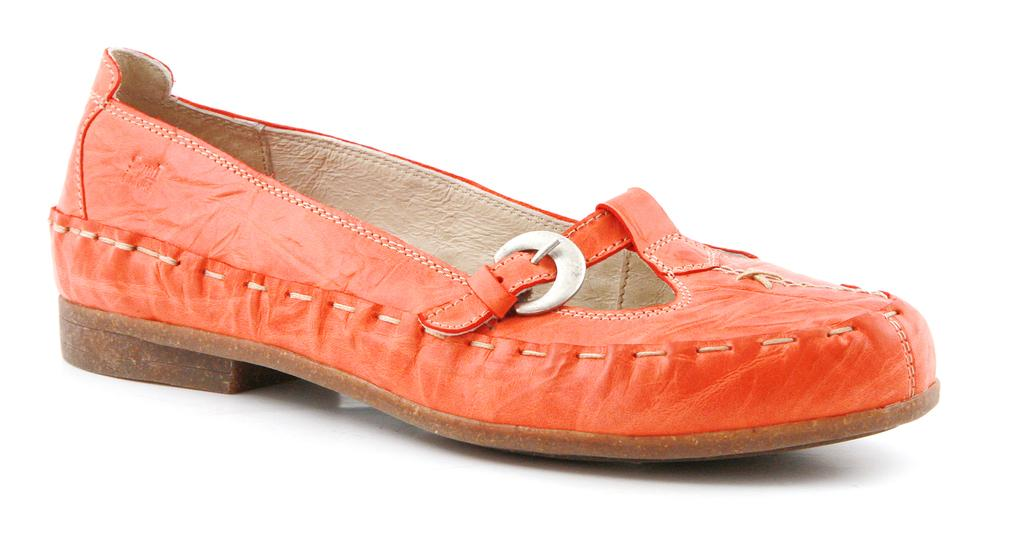What color is the shoe that is visible in the image? The shoe is orange in color. What can be inferred about the shoe's position in the image? The shoe is on a surface. What type of pancake is being served in the class depicted in the image? There is no class or pancake present in the image; it only features an orange color shoe on a surface. 